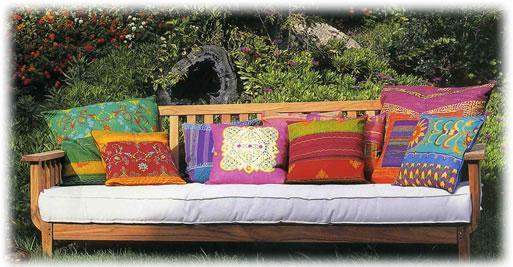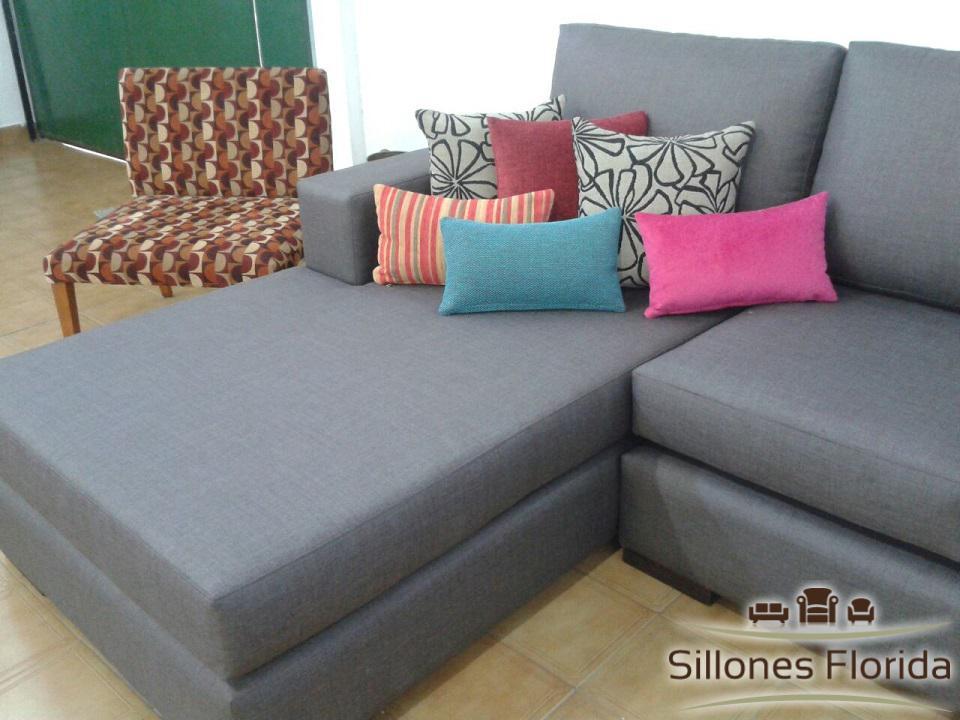The first image is the image on the left, the second image is the image on the right. Evaluate the accuracy of this statement regarding the images: "At least one of the sofas is a solid pink color.". Is it true? Answer yes or no. No. 